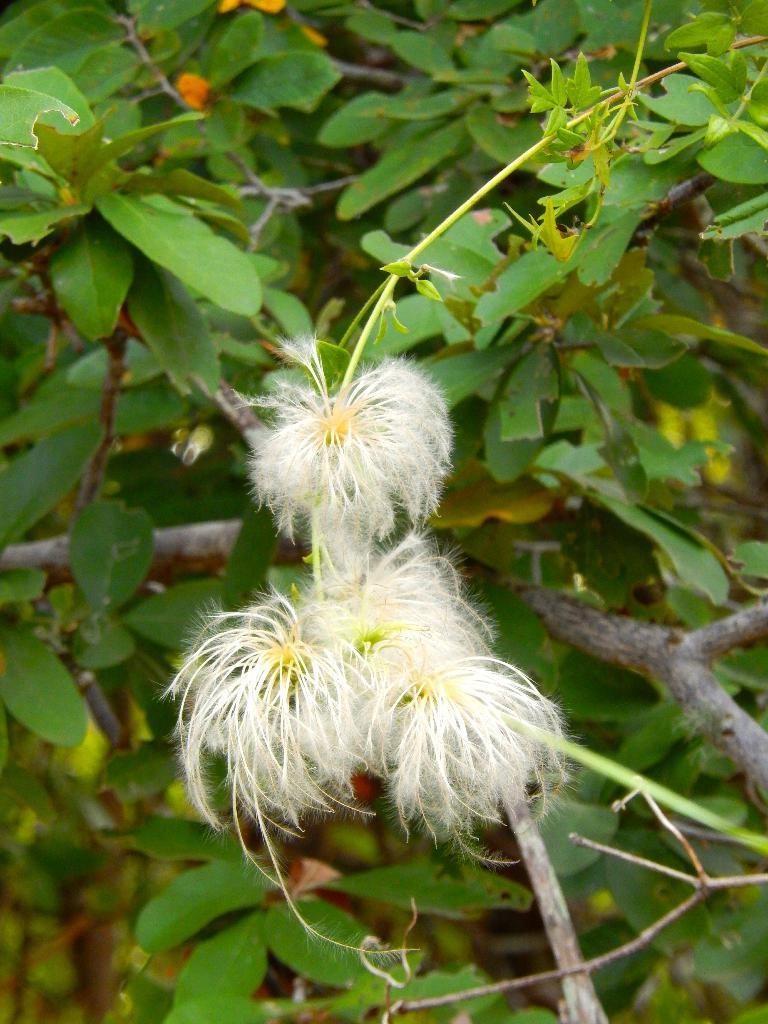What type of plant life is visible in the image? There are flowers, leaves, and branches of a tree in the image. Can you describe the specific parts of the plant life that are visible? The flowers are likely the most colorful and eye-catching part of the image, while the leaves and branches provide context for the overall scene. What type of pan is being used to cook the flowers in the image? There is no pan or cooking activity present in the image; it simply features flowers, leaves, and branches of a tree. 